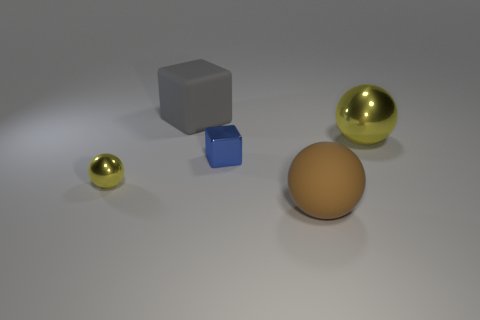What number of objects are brown balls or shiny spheres?
Offer a very short reply. 3. Are there an equal number of tiny blue metallic blocks right of the blue metal object and tiny yellow shiny cylinders?
Provide a succinct answer. Yes. There is a large metal sphere right of the metallic ball that is on the left side of the big brown ball; are there any tiny blue metal things behind it?
Your response must be concise. No. The big thing that is made of the same material as the large brown ball is what color?
Offer a very short reply. Gray. There is a metallic sphere that is on the left side of the big metallic thing; is its color the same as the large metallic sphere?
Provide a short and direct response. Yes. How many blocks are big yellow things or big things?
Ensure brevity in your answer.  1. What is the size of the sphere that is behind the yellow sphere that is to the left of the rubber thing that is on the left side of the matte sphere?
Make the answer very short. Large. There is a yellow metallic thing that is the same size as the blue object; what is its shape?
Ensure brevity in your answer.  Sphere. The large brown matte object has what shape?
Keep it short and to the point. Sphere. Is the material of the object in front of the small yellow object the same as the tiny yellow ball?
Your answer should be compact. No. 